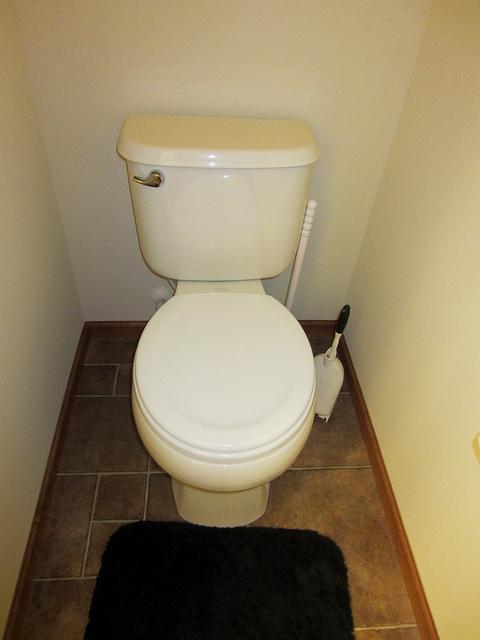How many toilets are there?
Give a very brief answer. 1. 